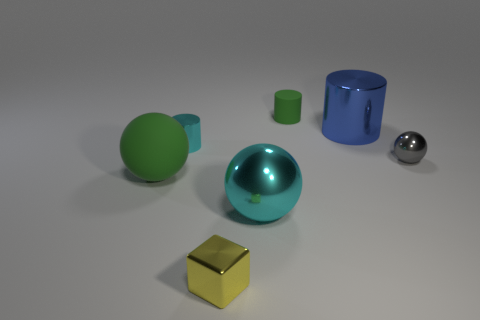How many things are both on the left side of the big cyan object and behind the green ball?
Ensure brevity in your answer.  1. How many other things are there of the same material as the cyan cylinder?
Keep it short and to the point. 4. There is a tiny metal object on the right side of the blue thing behind the large matte ball; what color is it?
Your response must be concise. Gray. There is a cylinder that is on the left side of the yellow cube; does it have the same color as the matte sphere?
Keep it short and to the point. No. Do the blue metal object and the yellow metallic cube have the same size?
Provide a succinct answer. No. The gray shiny object that is the same size as the cyan shiny cylinder is what shape?
Provide a short and direct response. Sphere. Does the matte object left of the green rubber cylinder have the same size as the big blue cylinder?
Offer a terse response. Yes. There is a cube that is the same size as the gray sphere; what is its material?
Your answer should be compact. Metal. There is a green object that is left of the green object behind the tiny cyan cylinder; is there a tiny yellow metallic cube to the left of it?
Provide a short and direct response. No. Is there any other thing that has the same shape as the big green object?
Your answer should be very brief. Yes. 